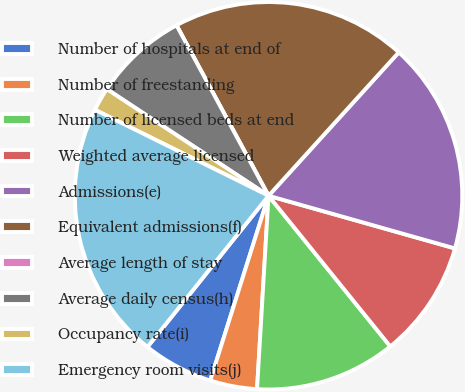<chart> <loc_0><loc_0><loc_500><loc_500><pie_chart><fcel>Number of hospitals at end of<fcel>Number of freestanding<fcel>Number of licensed beds at end<fcel>Weighted average licensed<fcel>Admissions(e)<fcel>Equivalent admissions(f)<fcel>Average length of stay<fcel>Average daily census(h)<fcel>Occupancy rate(i)<fcel>Emergency room visits(j)<nl><fcel>5.88%<fcel>3.92%<fcel>11.76%<fcel>9.8%<fcel>17.65%<fcel>19.61%<fcel>0.0%<fcel>7.84%<fcel>1.96%<fcel>21.57%<nl></chart> 